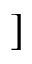Convert formula to latex. <formula><loc_0><loc_0><loc_500><loc_500>]</formula> 